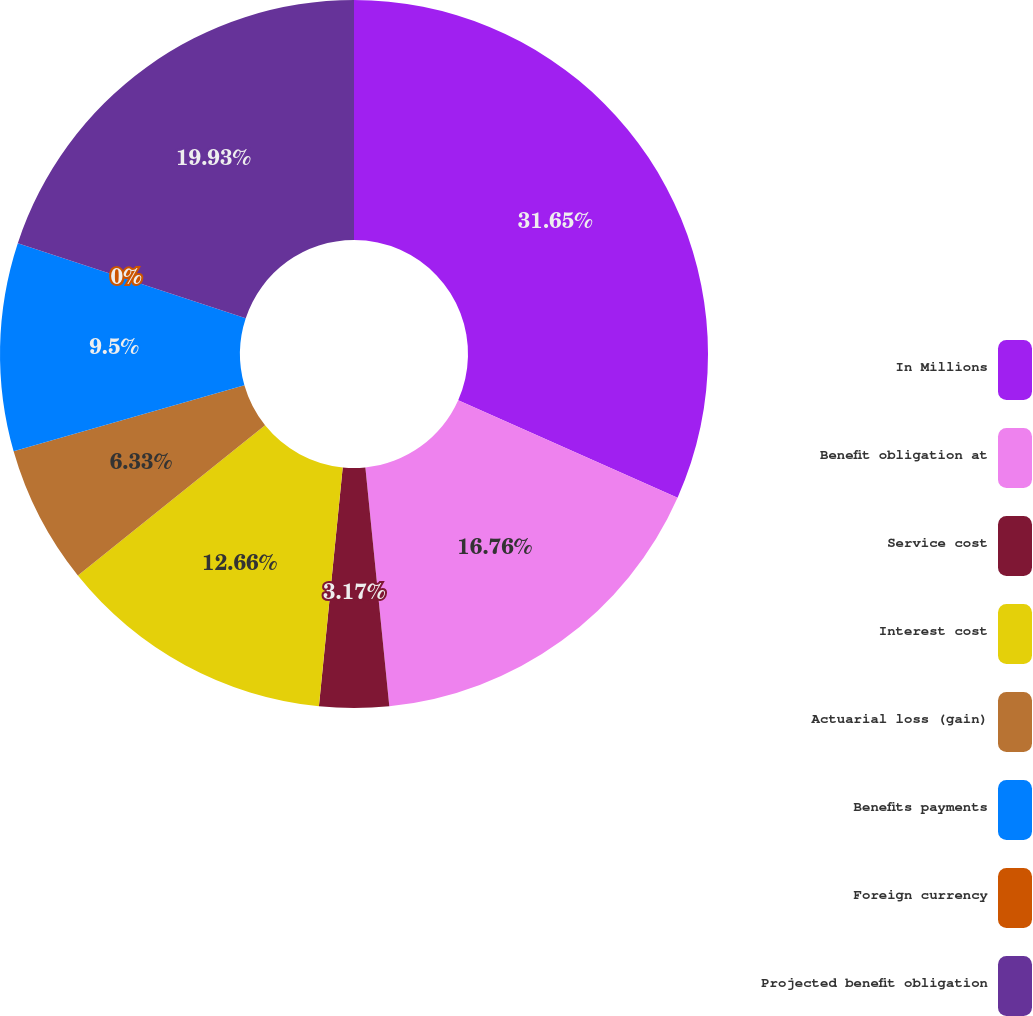Convert chart. <chart><loc_0><loc_0><loc_500><loc_500><pie_chart><fcel>In Millions<fcel>Benefit obligation at<fcel>Service cost<fcel>Interest cost<fcel>Actuarial loss (gain)<fcel>Benefits payments<fcel>Foreign currency<fcel>Projected benefit obligation<nl><fcel>31.65%<fcel>16.76%<fcel>3.17%<fcel>12.66%<fcel>6.33%<fcel>9.5%<fcel>0.0%<fcel>19.93%<nl></chart> 